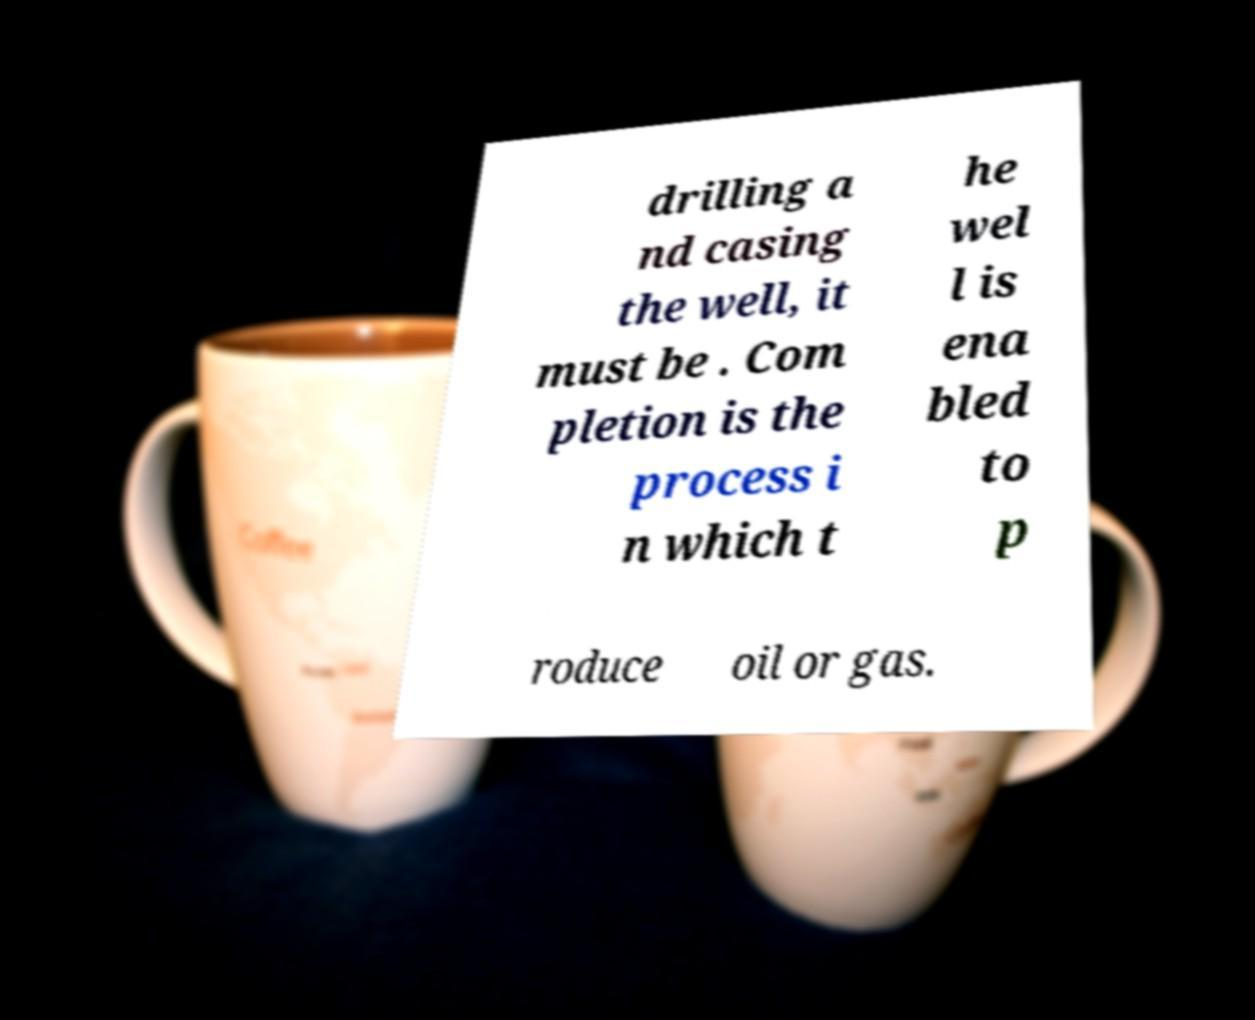What messages or text are displayed in this image? I need them in a readable, typed format. drilling a nd casing the well, it must be . Com pletion is the process i n which t he wel l is ena bled to p roduce oil or gas. 